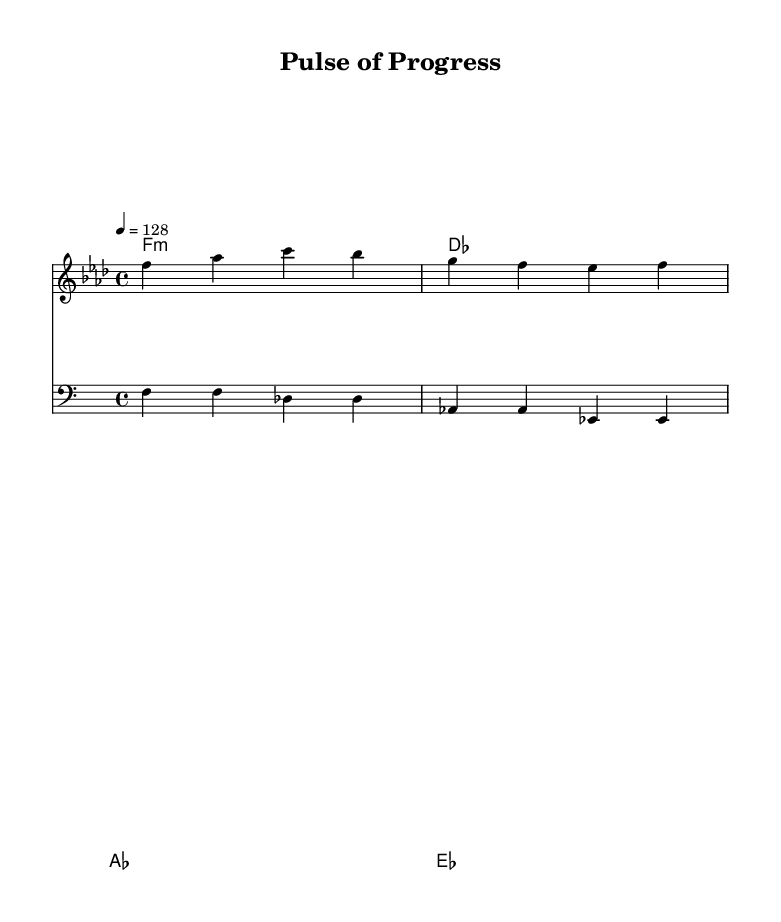What is the key signature of this music? The key signature is indicated by the number of flats present in the piece. Here, there are six flats shown, which corresponds to the key of F minor.
Answer: F minor What is the time signature of this music? The time signature is determined by the numbers at the beginning of the piece. Here, it shows 4/4, meaning there are four beats in each measure and the quarter note gets one beat.
Answer: 4/4 What is the tempo marking? The tempo marking is indicated at the beginning with a numerical value followed by '=,' specifically showing how many beats per minute. It reads 4 = 128, indicating the tempo of the piece is 128 beats per minute.
Answer: 128 How many measures are in the melody? To find the number of measures, count the sections divided by vertical lines in the melody. There are three measures in the provided melody lines.
Answer: 3 What is the primary lyrical theme of the song? The lyrics reveal the theme by mentioning historical figures in medicine and discoveries. The first verse addresses both Vesalius and Harvey, representing a narrative of medical history.
Answer: Medical discoveries Which chord type is used at the beginning of the piece? The chord at the beginning of the harmonic section is represented as 'f1:m', indicating that it is an F minor chord. The 'm' signifies the minor quality of the chord.
Answer: F minor How does the bassline interact with the melody? The bassline plays a steady pattern accompanying the melody, providing depth and rhythm. Observing the layout, the bass consistently supports the harmonic structure outlined above it, complementing each melodic note.
Answer: Steady pattern 